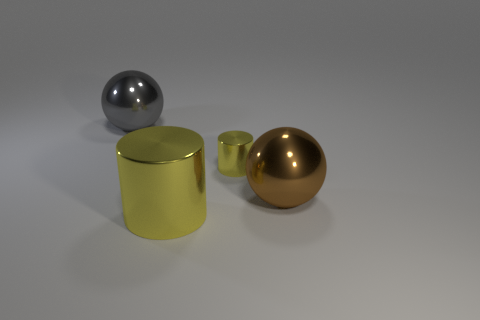Add 3 purple cubes. How many objects exist? 7 Subtract all gray spheres. How many spheres are left? 1 Subtract 1 cylinders. How many cylinders are left? 1 Subtract 1 brown balls. How many objects are left? 3 Subtract all green cylinders. Subtract all brown cubes. How many cylinders are left? 2 Subtract all gray metal things. Subtract all gray metallic balls. How many objects are left? 2 Add 2 large yellow metal objects. How many large yellow metal objects are left? 3 Add 2 large gray metallic spheres. How many large gray metallic spheres exist? 3 